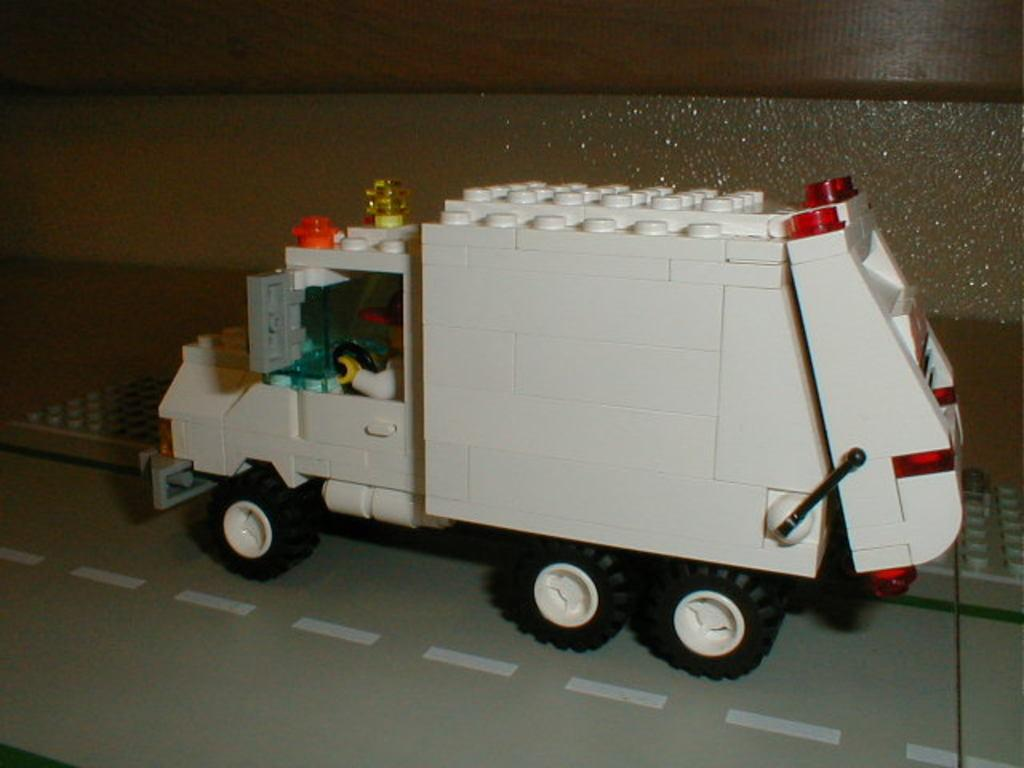What type of vehicle is in the image? There is a white color truck in the image. Where is the truck located? The truck is on a road. What else can be seen in the image besides the truck? There is water visible in the image. How many babies are sitting in the back of the truck in the image? There are no babies present in the image; it only features a white color truck on a road. 